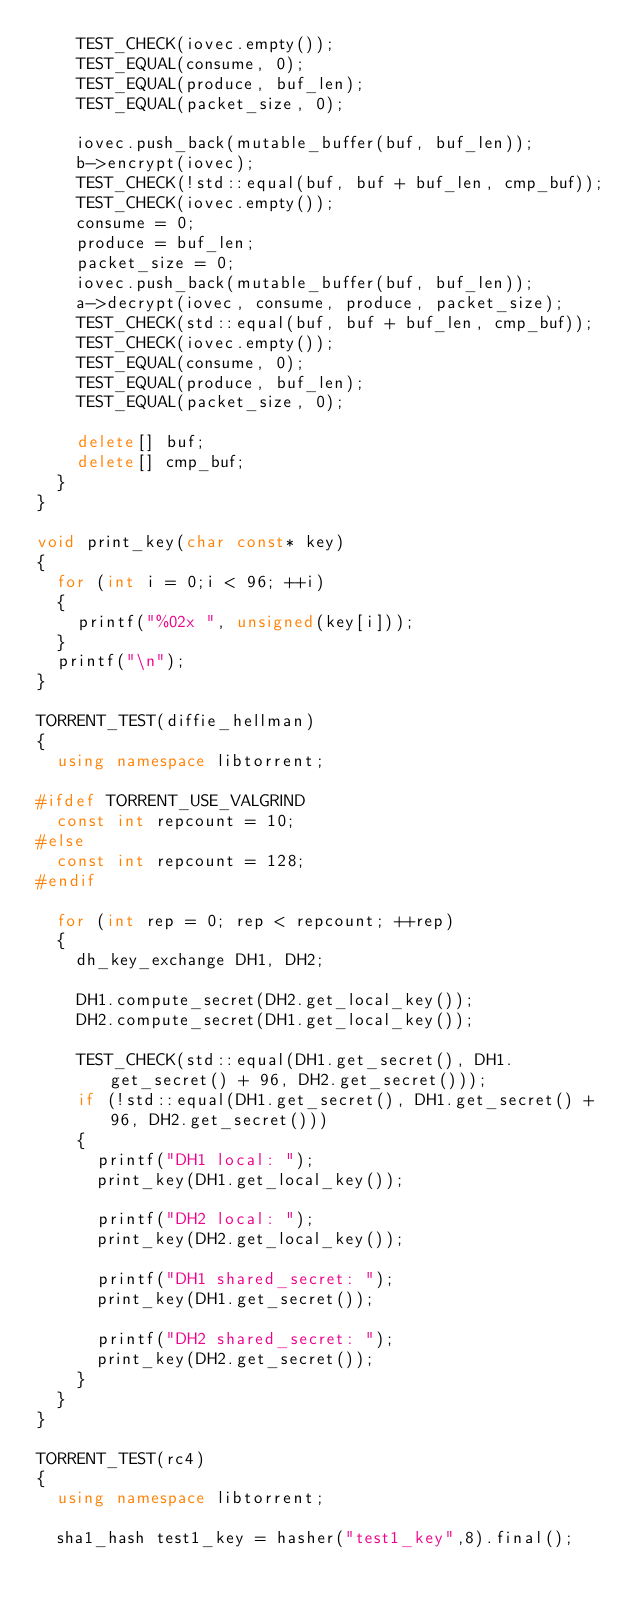Convert code to text. <code><loc_0><loc_0><loc_500><loc_500><_C++_>		TEST_CHECK(iovec.empty());
		TEST_EQUAL(consume, 0);
		TEST_EQUAL(produce, buf_len);
		TEST_EQUAL(packet_size, 0);

		iovec.push_back(mutable_buffer(buf, buf_len));
		b->encrypt(iovec);
		TEST_CHECK(!std::equal(buf, buf + buf_len, cmp_buf));
		TEST_CHECK(iovec.empty());
		consume = 0;
		produce = buf_len;
		packet_size = 0;
		iovec.push_back(mutable_buffer(buf, buf_len));
		a->decrypt(iovec, consume, produce, packet_size);
		TEST_CHECK(std::equal(buf, buf + buf_len, cmp_buf));
		TEST_CHECK(iovec.empty());
		TEST_EQUAL(consume, 0);
		TEST_EQUAL(produce, buf_len);
		TEST_EQUAL(packet_size, 0);

		delete[] buf;
		delete[] cmp_buf;
	}
}

void print_key(char const* key)
{
	for (int i = 0;i < 96; ++i)
	{
		printf("%02x ", unsigned(key[i]));
	}
	printf("\n");
}

TORRENT_TEST(diffie_hellman)
{
	using namespace libtorrent;

#ifdef TORRENT_USE_VALGRIND
	const int repcount = 10;
#else
	const int repcount = 128;
#endif

	for (int rep = 0; rep < repcount; ++rep)
	{
		dh_key_exchange DH1, DH2;

		DH1.compute_secret(DH2.get_local_key());
		DH2.compute_secret(DH1.get_local_key());

		TEST_CHECK(std::equal(DH1.get_secret(), DH1.get_secret() + 96, DH2.get_secret()));
		if (!std::equal(DH1.get_secret(), DH1.get_secret() + 96, DH2.get_secret()))
		{
			printf("DH1 local: ");
			print_key(DH1.get_local_key());

			printf("DH2 local: ");
			print_key(DH2.get_local_key());

			printf("DH1 shared_secret: ");
			print_key(DH1.get_secret());

			printf("DH2 shared_secret: ");
			print_key(DH2.get_secret());
		}
	}
}

TORRENT_TEST(rc4)
{
	using namespace libtorrent;

	sha1_hash test1_key = hasher("test1_key",8).final();</code> 